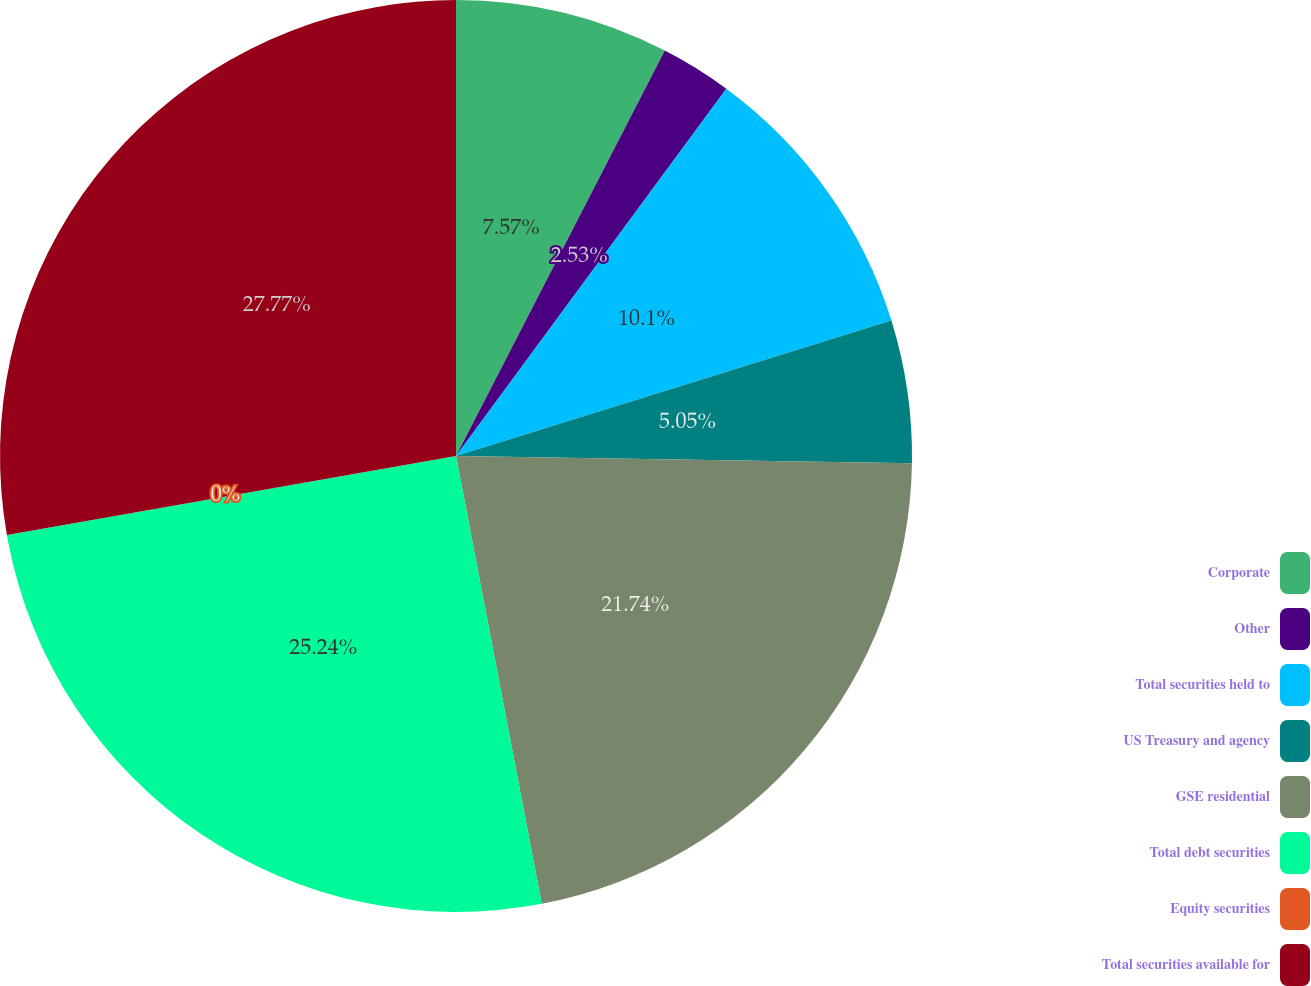<chart> <loc_0><loc_0><loc_500><loc_500><pie_chart><fcel>Corporate<fcel>Other<fcel>Total securities held to<fcel>US Treasury and agency<fcel>GSE residential<fcel>Total debt securities<fcel>Equity securities<fcel>Total securities available for<nl><fcel>7.57%<fcel>2.53%<fcel>10.1%<fcel>5.05%<fcel>21.74%<fcel>25.24%<fcel>0.0%<fcel>27.77%<nl></chart> 